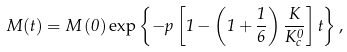<formula> <loc_0><loc_0><loc_500><loc_500>M ( t ) = M \left ( 0 \right ) \exp \left \{ - p \left [ 1 - \left ( 1 + \frac { 1 } { 6 } \right ) \frac { K } { K _ { c } ^ { 0 } } \right ] t \right \} ,</formula> 